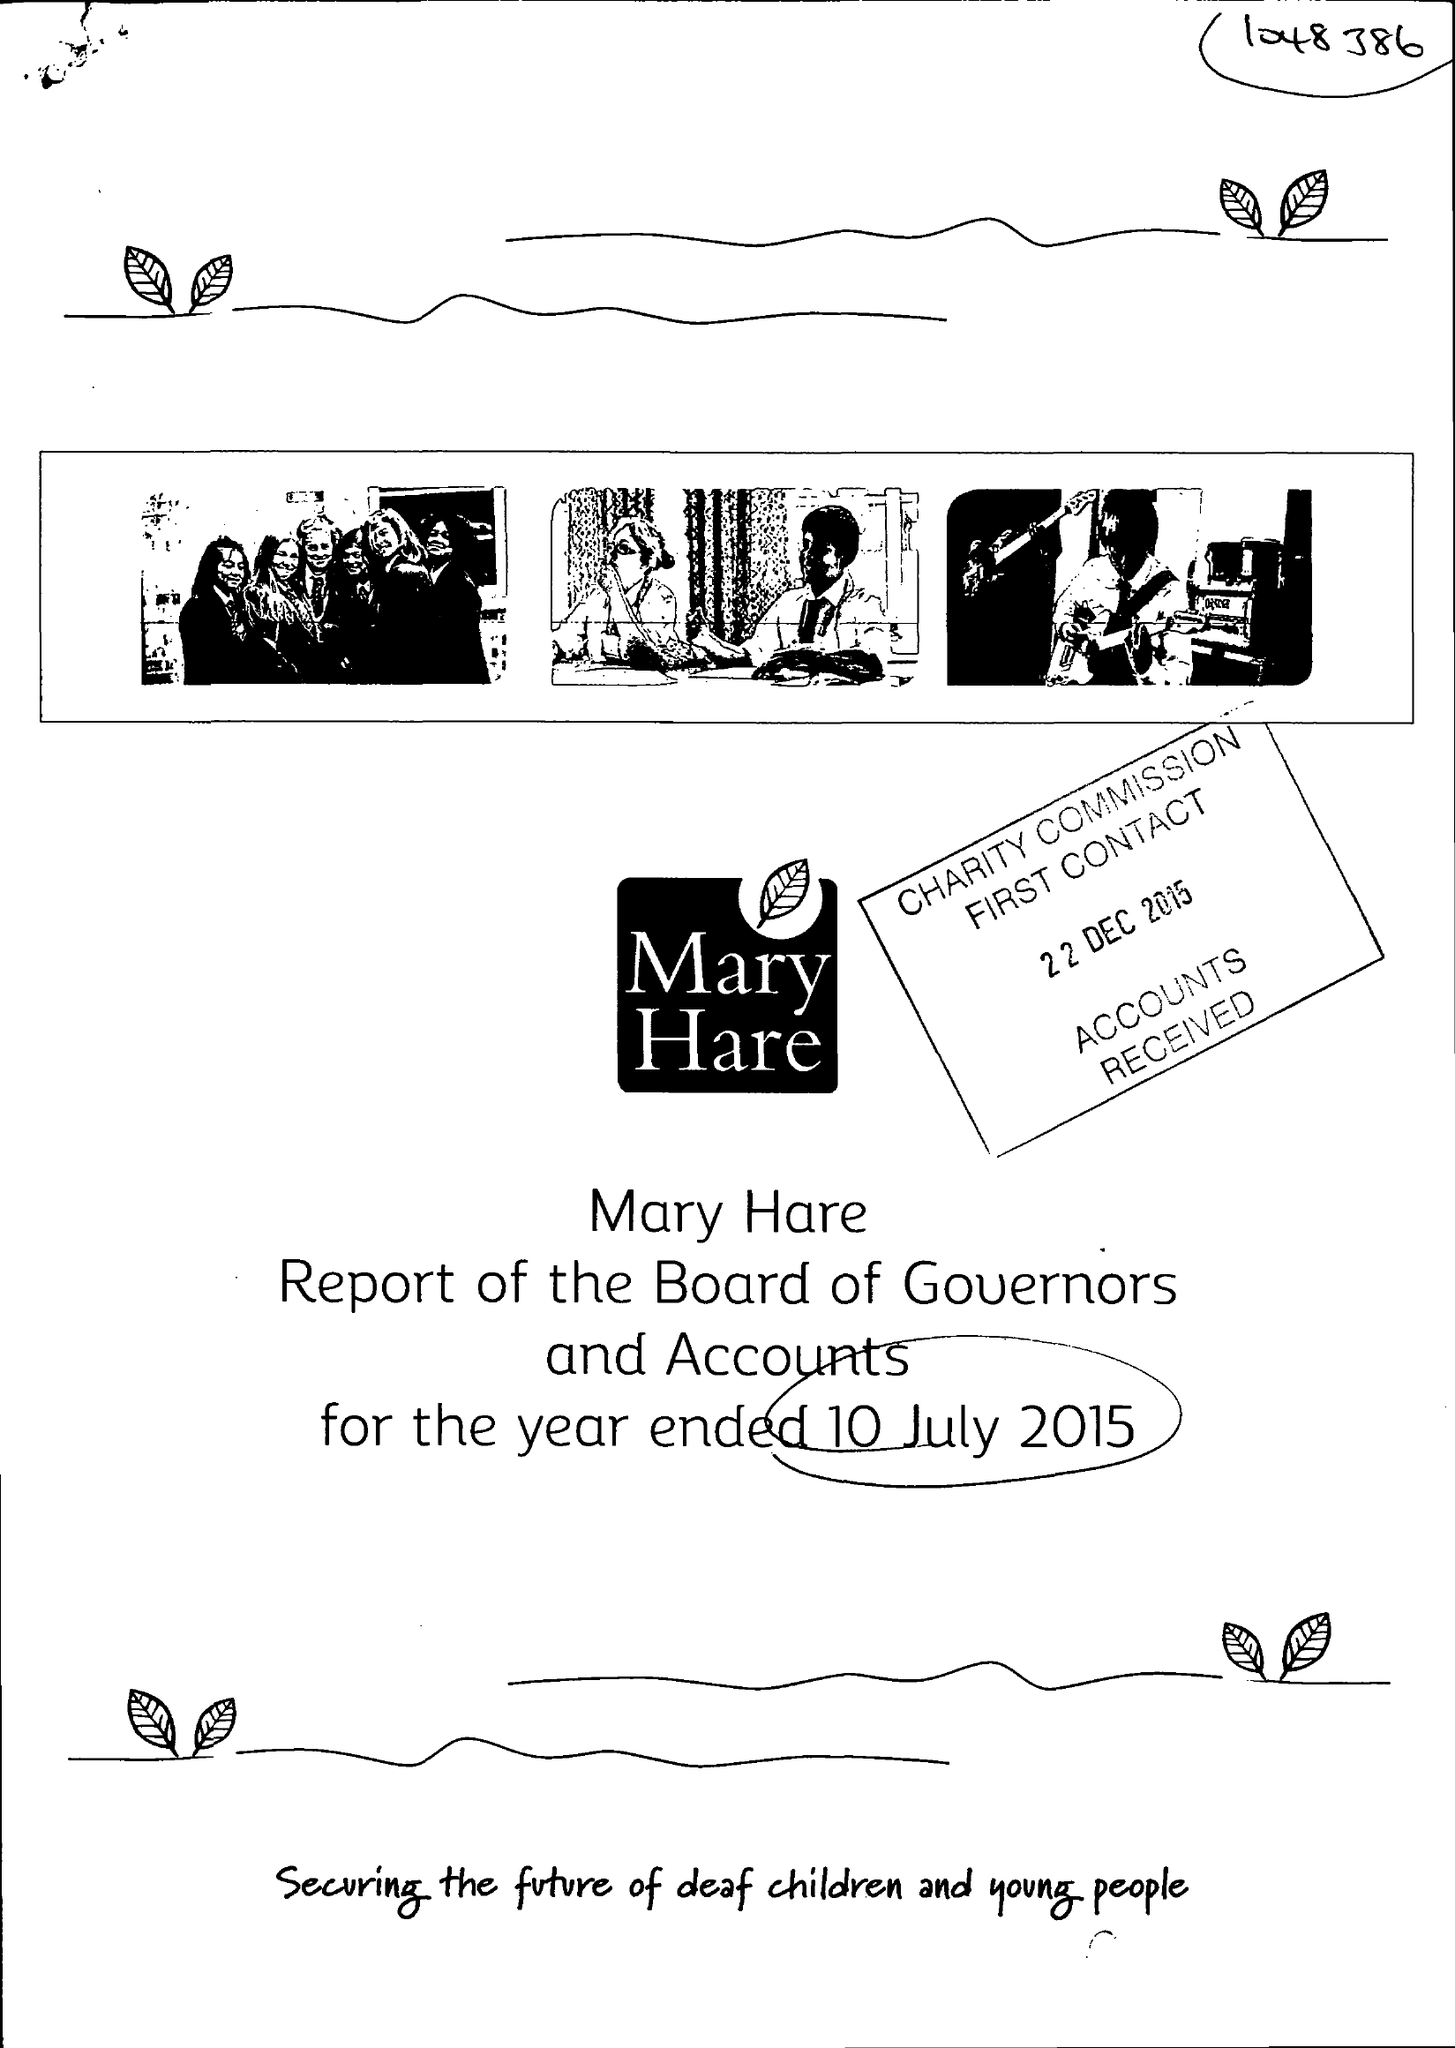What is the value for the charity_name?
Answer the question using a single word or phrase. Mary Hare 